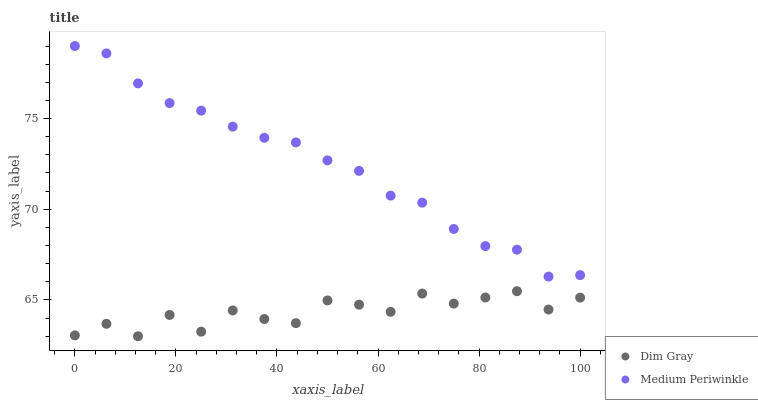Does Dim Gray have the minimum area under the curve?
Answer yes or no. Yes. Does Medium Periwinkle have the maximum area under the curve?
Answer yes or no. Yes. Does Medium Periwinkle have the minimum area under the curve?
Answer yes or no. No. Is Medium Periwinkle the smoothest?
Answer yes or no. Yes. Is Dim Gray the roughest?
Answer yes or no. Yes. Is Medium Periwinkle the roughest?
Answer yes or no. No. Does Dim Gray have the lowest value?
Answer yes or no. Yes. Does Medium Periwinkle have the lowest value?
Answer yes or no. No. Does Medium Periwinkle have the highest value?
Answer yes or no. Yes. Is Dim Gray less than Medium Periwinkle?
Answer yes or no. Yes. Is Medium Periwinkle greater than Dim Gray?
Answer yes or no. Yes. Does Dim Gray intersect Medium Periwinkle?
Answer yes or no. No. 